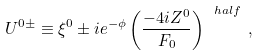Convert formula to latex. <formula><loc_0><loc_0><loc_500><loc_500>U ^ { 0 \pm } \equiv \xi ^ { 0 } \pm i e ^ { - \phi } \left ( \frac { - 4 i Z ^ { 0 } } { F _ { 0 } } \right ) ^ { \ h a l f } \, ,</formula> 